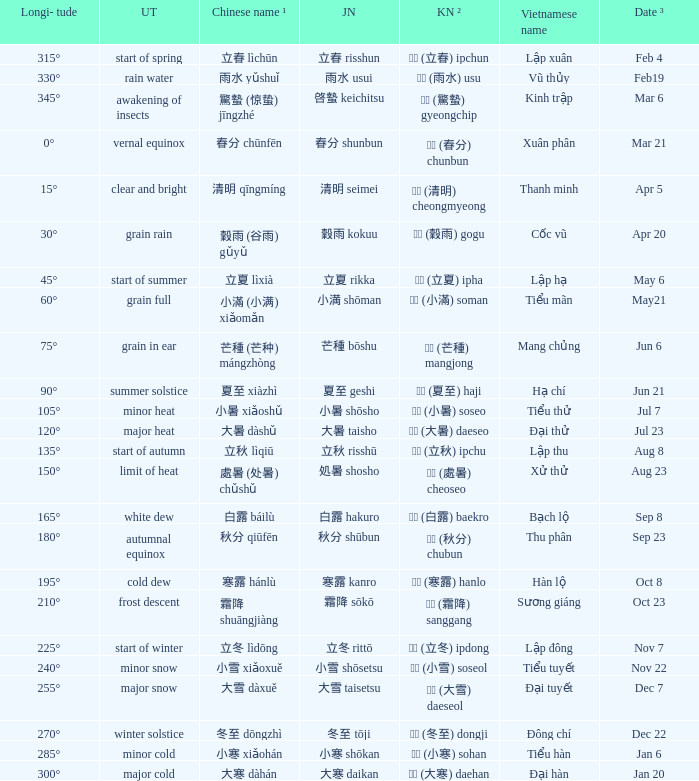WHICH Vietnamese name has a Chinese name ¹ of 芒種 (芒种) mángzhòng? Mang chủng. 